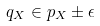<formula> <loc_0><loc_0><loc_500><loc_500>q _ { X } \in p _ { X } \pm \epsilon</formula> 